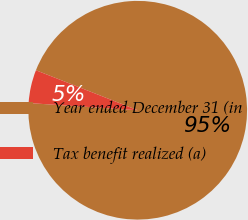<chart> <loc_0><loc_0><loc_500><loc_500><pie_chart><fcel>Year ended December 31 (in<fcel>Tax benefit realized (a)<nl><fcel>95.09%<fcel>4.91%<nl></chart> 